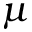Convert formula to latex. <formula><loc_0><loc_0><loc_500><loc_500>\mu</formula> 